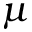Convert formula to latex. <formula><loc_0><loc_0><loc_500><loc_500>\mu</formula> 